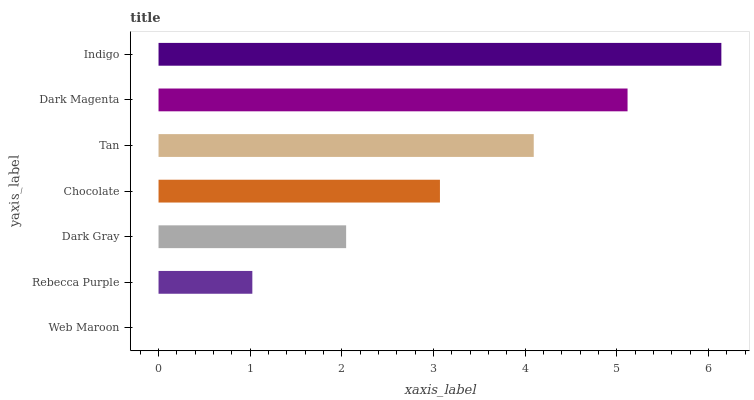Is Web Maroon the minimum?
Answer yes or no. Yes. Is Indigo the maximum?
Answer yes or no. Yes. Is Rebecca Purple the minimum?
Answer yes or no. No. Is Rebecca Purple the maximum?
Answer yes or no. No. Is Rebecca Purple greater than Web Maroon?
Answer yes or no. Yes. Is Web Maroon less than Rebecca Purple?
Answer yes or no. Yes. Is Web Maroon greater than Rebecca Purple?
Answer yes or no. No. Is Rebecca Purple less than Web Maroon?
Answer yes or no. No. Is Chocolate the high median?
Answer yes or no. Yes. Is Chocolate the low median?
Answer yes or no. Yes. Is Rebecca Purple the high median?
Answer yes or no. No. Is Indigo the low median?
Answer yes or no. No. 